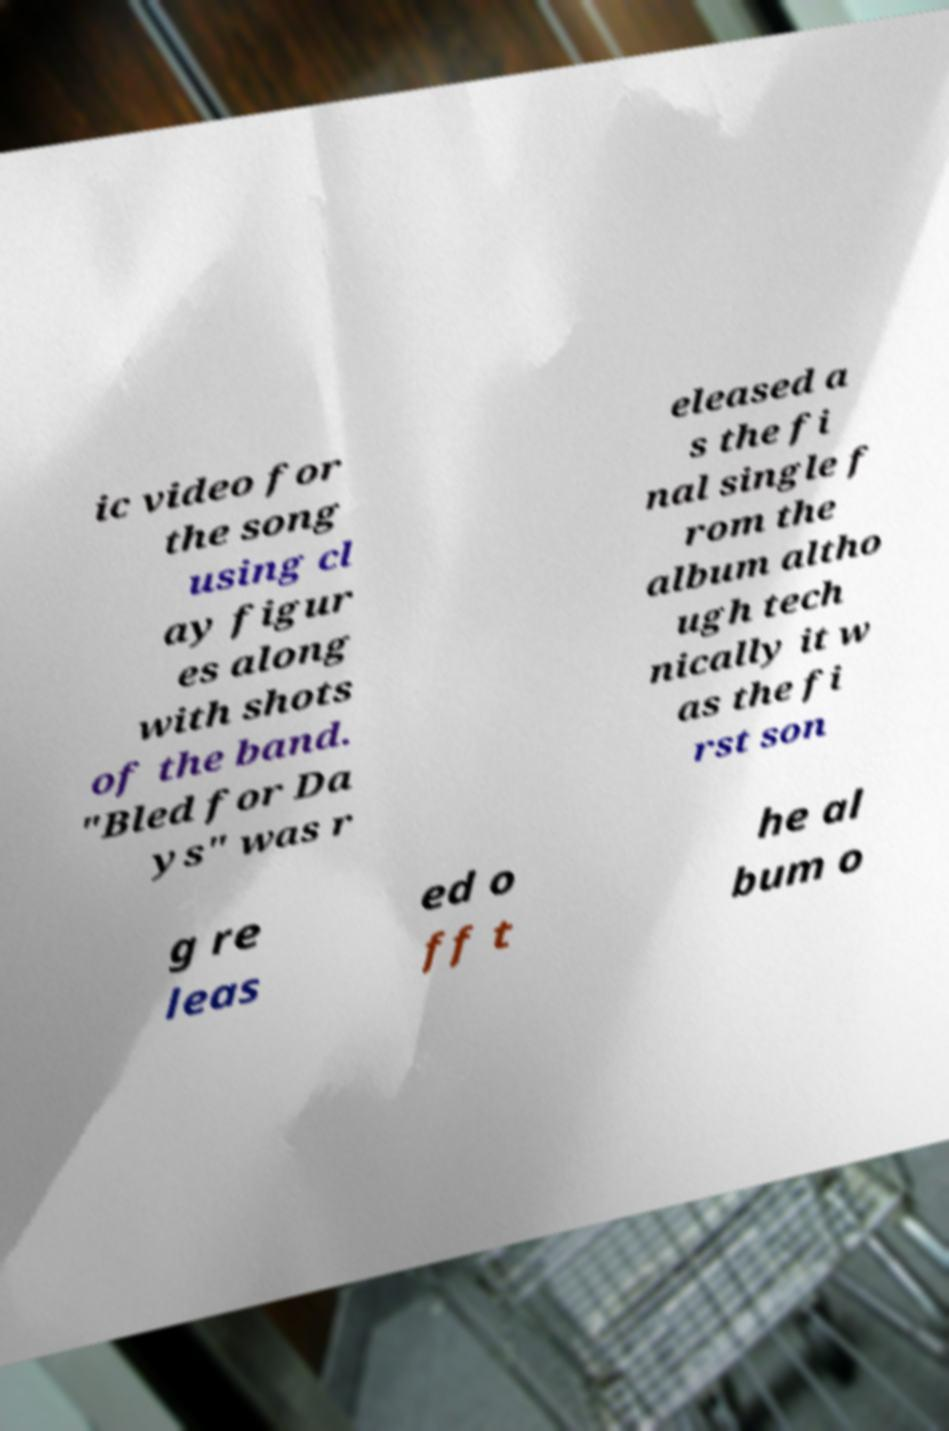Can you accurately transcribe the text from the provided image for me? ic video for the song using cl ay figur es along with shots of the band. "Bled for Da ys" was r eleased a s the fi nal single f rom the album altho ugh tech nically it w as the fi rst son g re leas ed o ff t he al bum o 